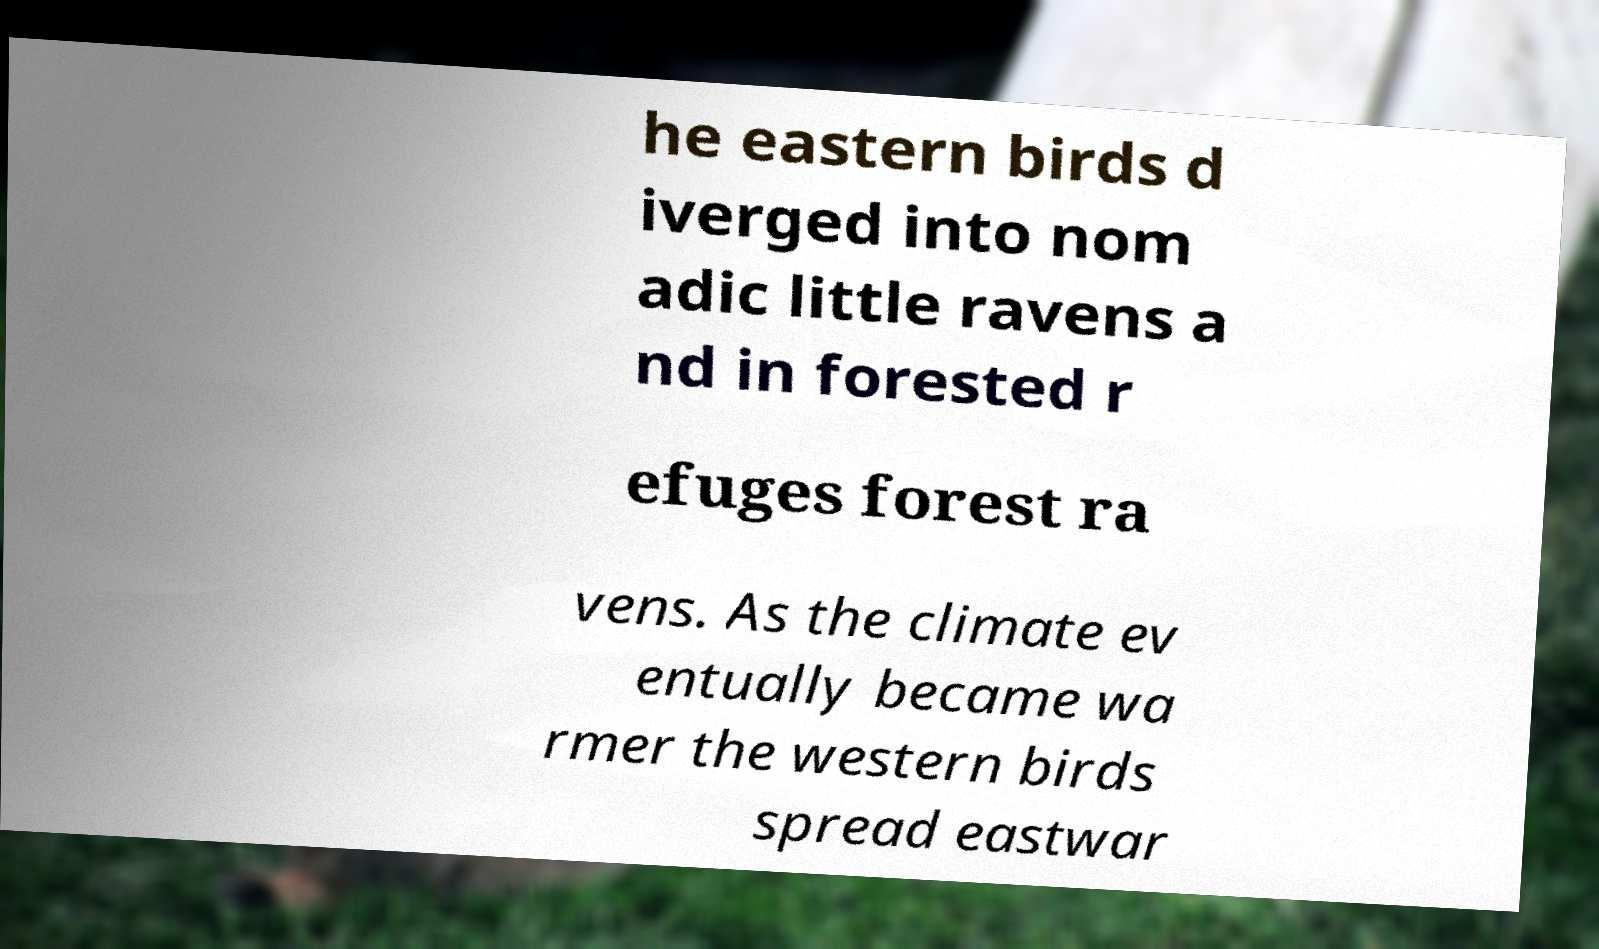For documentation purposes, I need the text within this image transcribed. Could you provide that? he eastern birds d iverged into nom adic little ravens a nd in forested r efuges forest ra vens. As the climate ev entually became wa rmer the western birds spread eastwar 